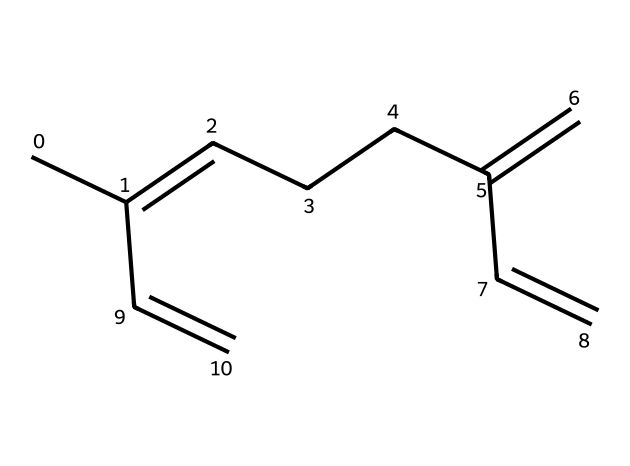What is the name of this chemical? The SMILES representation corresponds to myrcene, which is a well-known terpene.
Answer: myrcene How many carbon atoms are present in myrcene? By counting the carbon atoms in the structure represented by the SMILES, there are 10 carbon atoms in total.
Answer: 10 How many double bonds are found in myrcene? Analyzing the structure reveals that there are 3 double bonds indicated in the SMILES representation.
Answer: 3 Is myrcene a cyclic or acyclic compound? The structure represents a linear arrangement of carbon atoms without any rings, indicating that myrcene is acyclic.
Answer: acyclic What type of compound is myrcene classified as? Since myrcene has a structure typical of terpenes, which are hydrocarbons produced by plants, it is classified specifically as a terpene.
Answer: terpene What molecular feature contributes to the characteristic aroma of myrcene? The presence of multiple double bonds (the unsaturated carbon structure) is significant as it affects the reactivity, volatility, and hence contributes to its aroma.
Answer: double bonds 